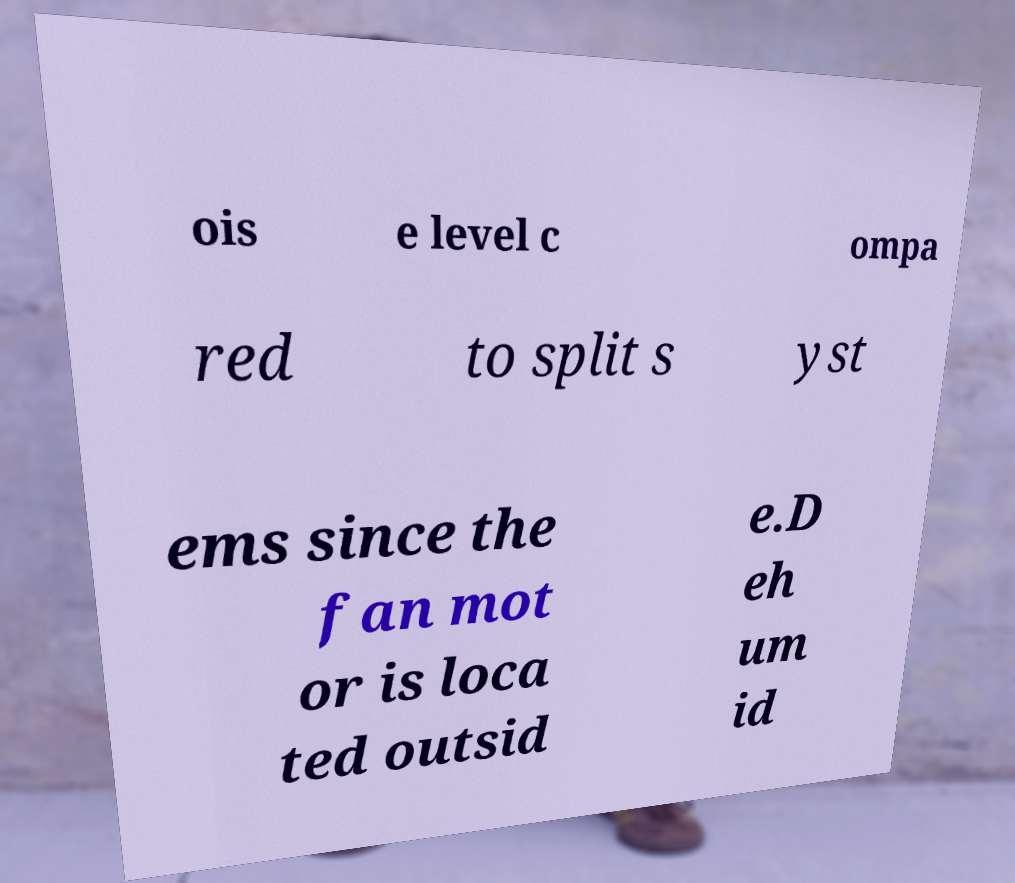Please identify and transcribe the text found in this image. ois e level c ompa red to split s yst ems since the fan mot or is loca ted outsid e.D eh um id 